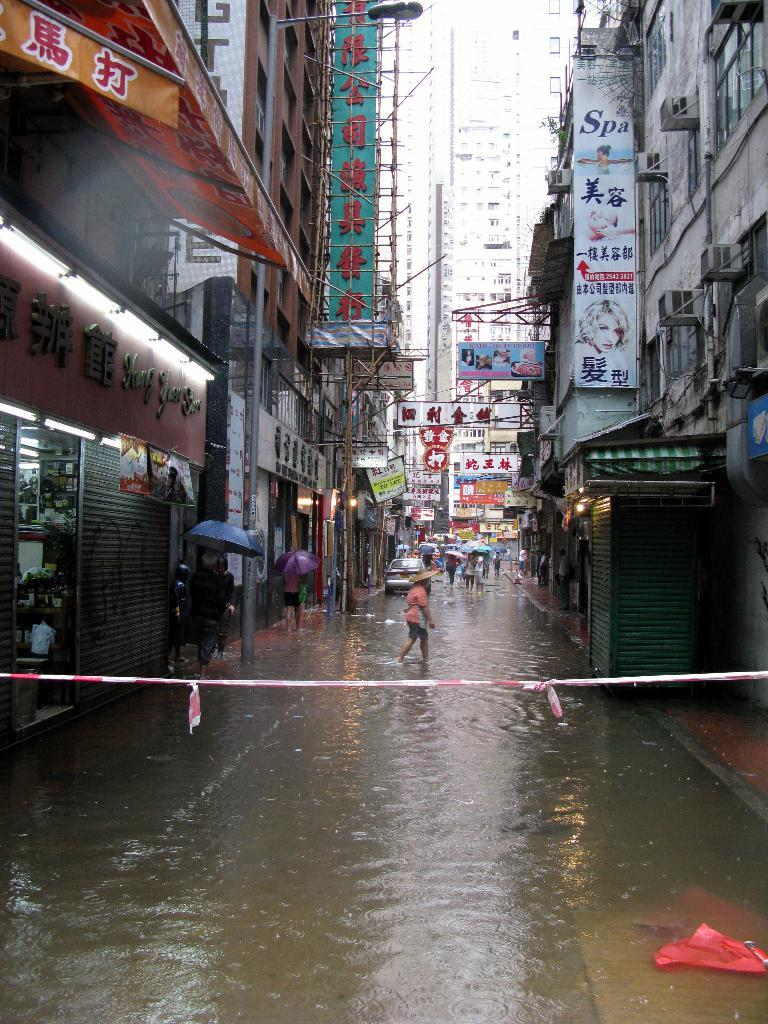Who or what can be seen in the image? There are people in the image. What else is present in the image besides people? There are vehicles and water visible in the image. What can be seen on the left side of the image? There are buildings on the left side of the image. What can be seen on the right side of the image? There are buildings on the right side of the image. What type of haircut is the bed receiving in the image? There is no haircut or bed present in the image. What connection can be made between the people and the vehicles in the image? The provided facts do not mention any connection between the people and the vehicles; we can only observe their presence in the image. 